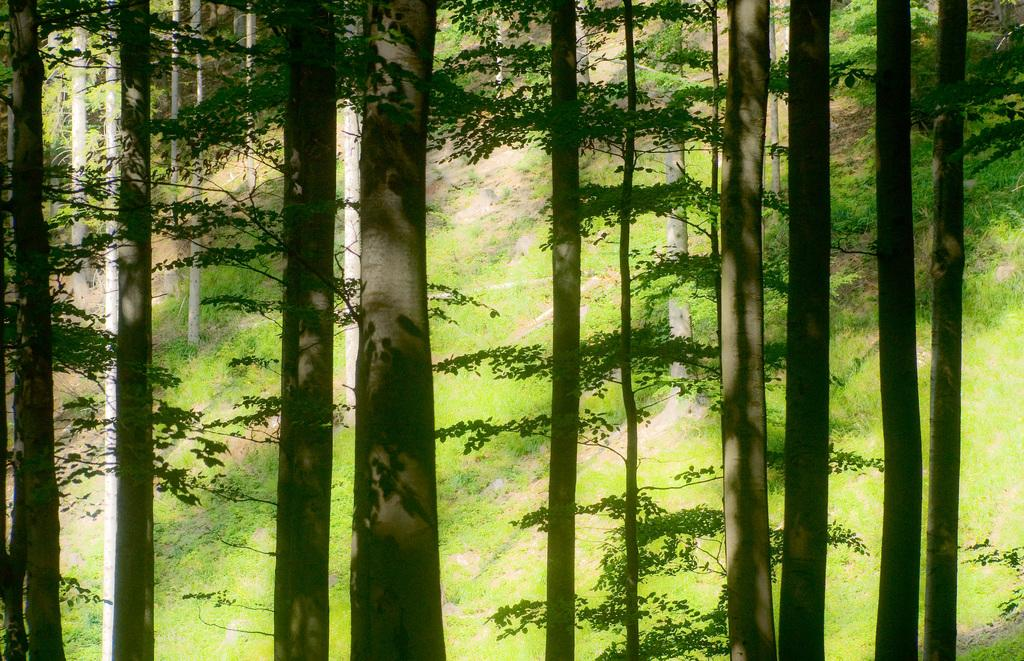What type of vegetation can be seen in the image? There are trees and grass in the image. Can you describe the natural environment depicted in the image? The image features trees and grass, which suggests a natural setting. What type of hope can be seen growing in the image? There is no hope present in the image; it features trees and grass. What type of line is visible connecting the trees in the image? There is no line connecting the trees in the image; it only shows trees and grass. 